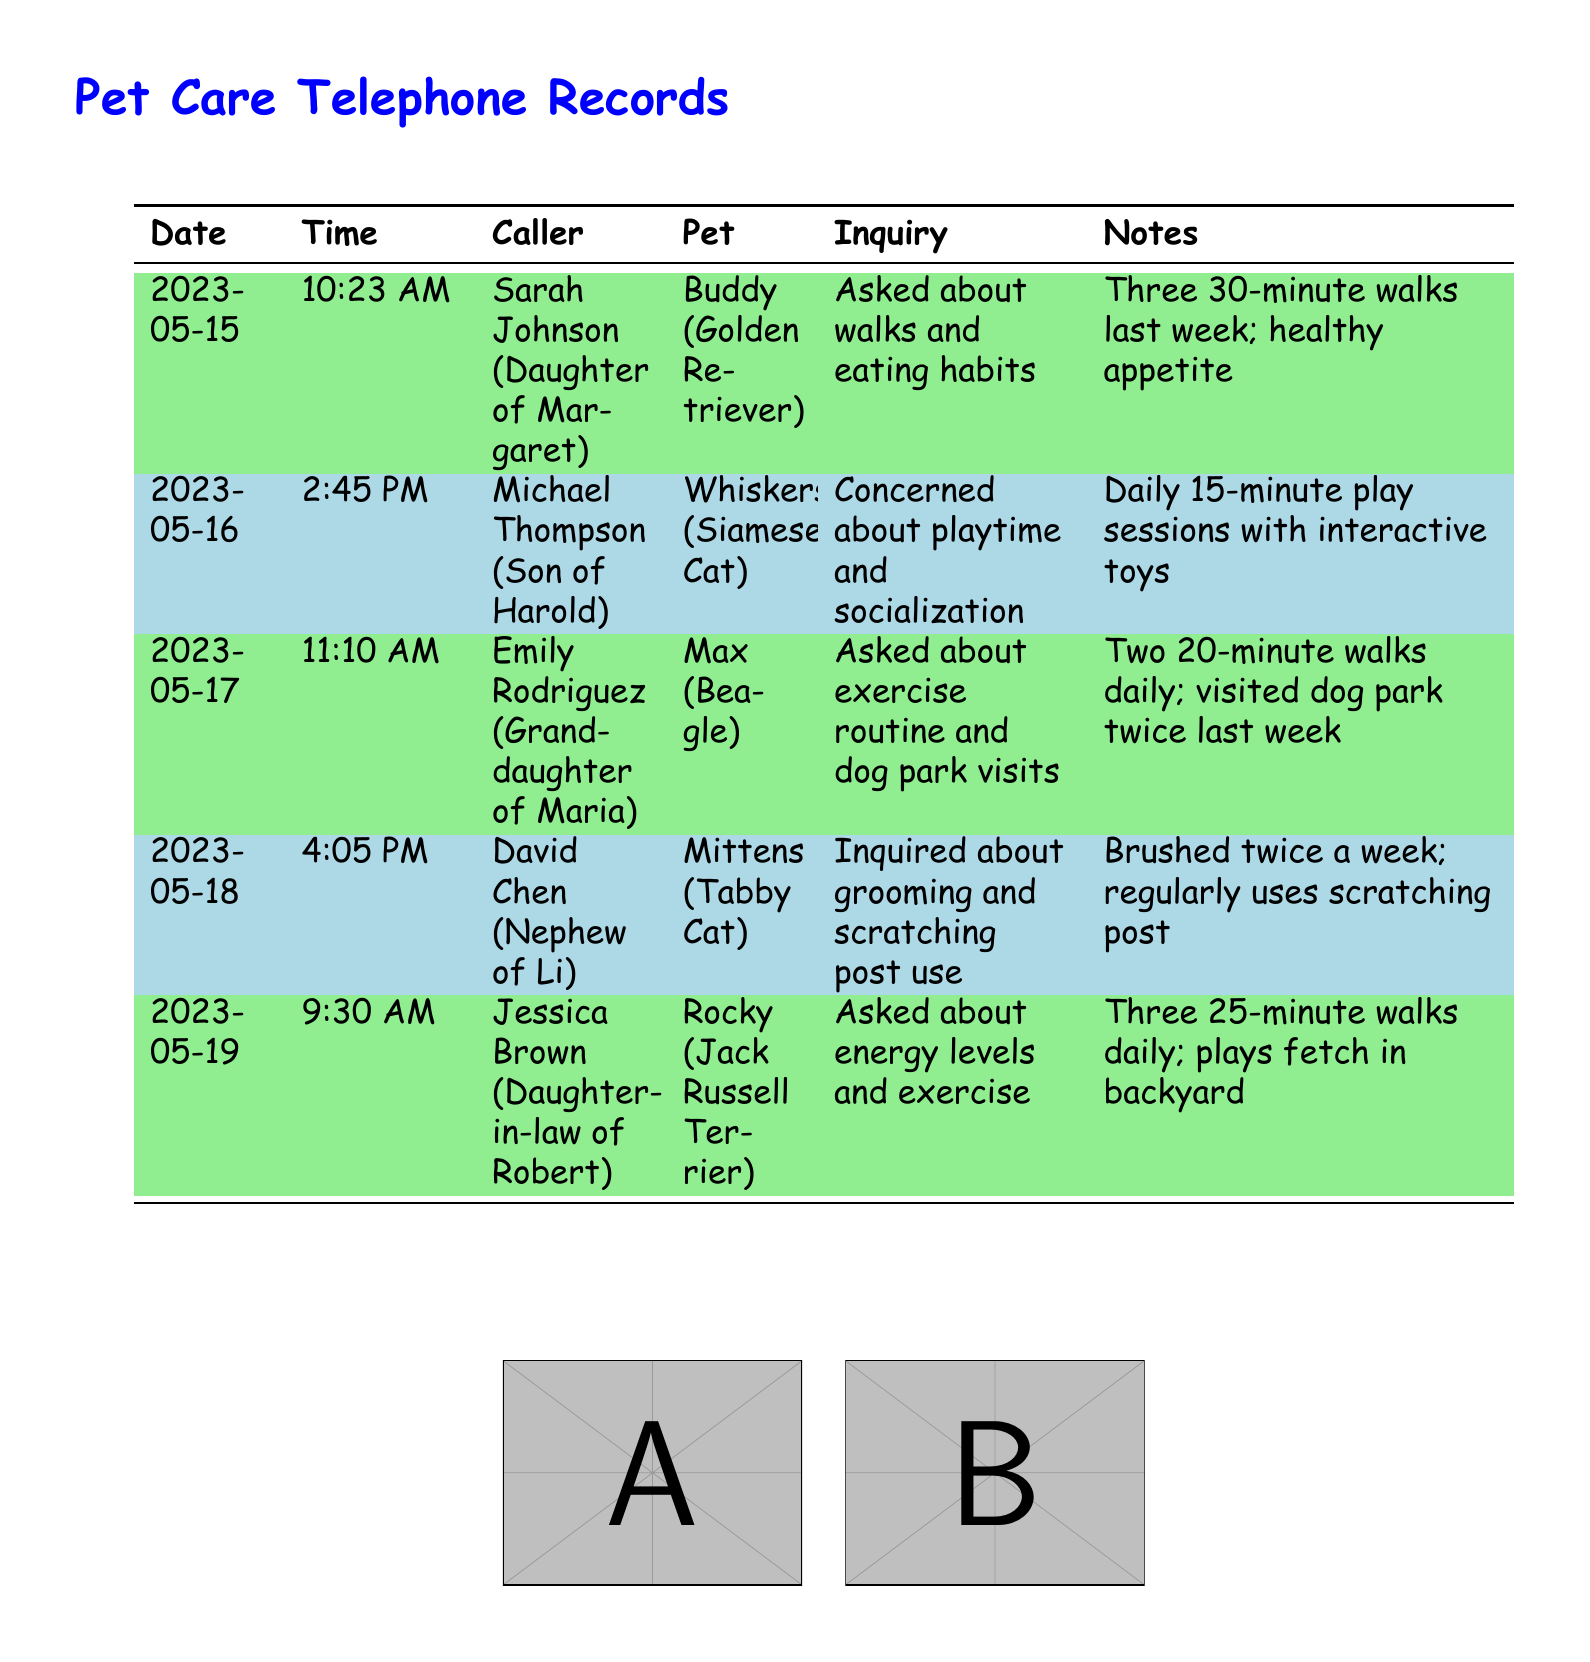What date did Sarah Johnson call? Sarah Johnson's call date can be found in the records under her entry.
Answer: 2023-05-15 How long did Jessica Brown mention Rocky exercises daily? Jessica Brown provided information about Rocky's exercise routine, which is also recorded in the notes section.
Answer: Three 25-minute walks What type of pet does Michael Thompson have? The document specifies the type of pet associated with each caller in the inquiry column.
Answer: Siamese Cat How many times did Max visit the dog park last week? The visit frequency to the dog park is mentioned in the inquiry notes specific to Max.
Answer: Twice What was the concern of David Chen during his call? David Chen's inquiry regarding Mittens is explicitly stated in the details of his call.
Answer: Grooming and scratching post use 